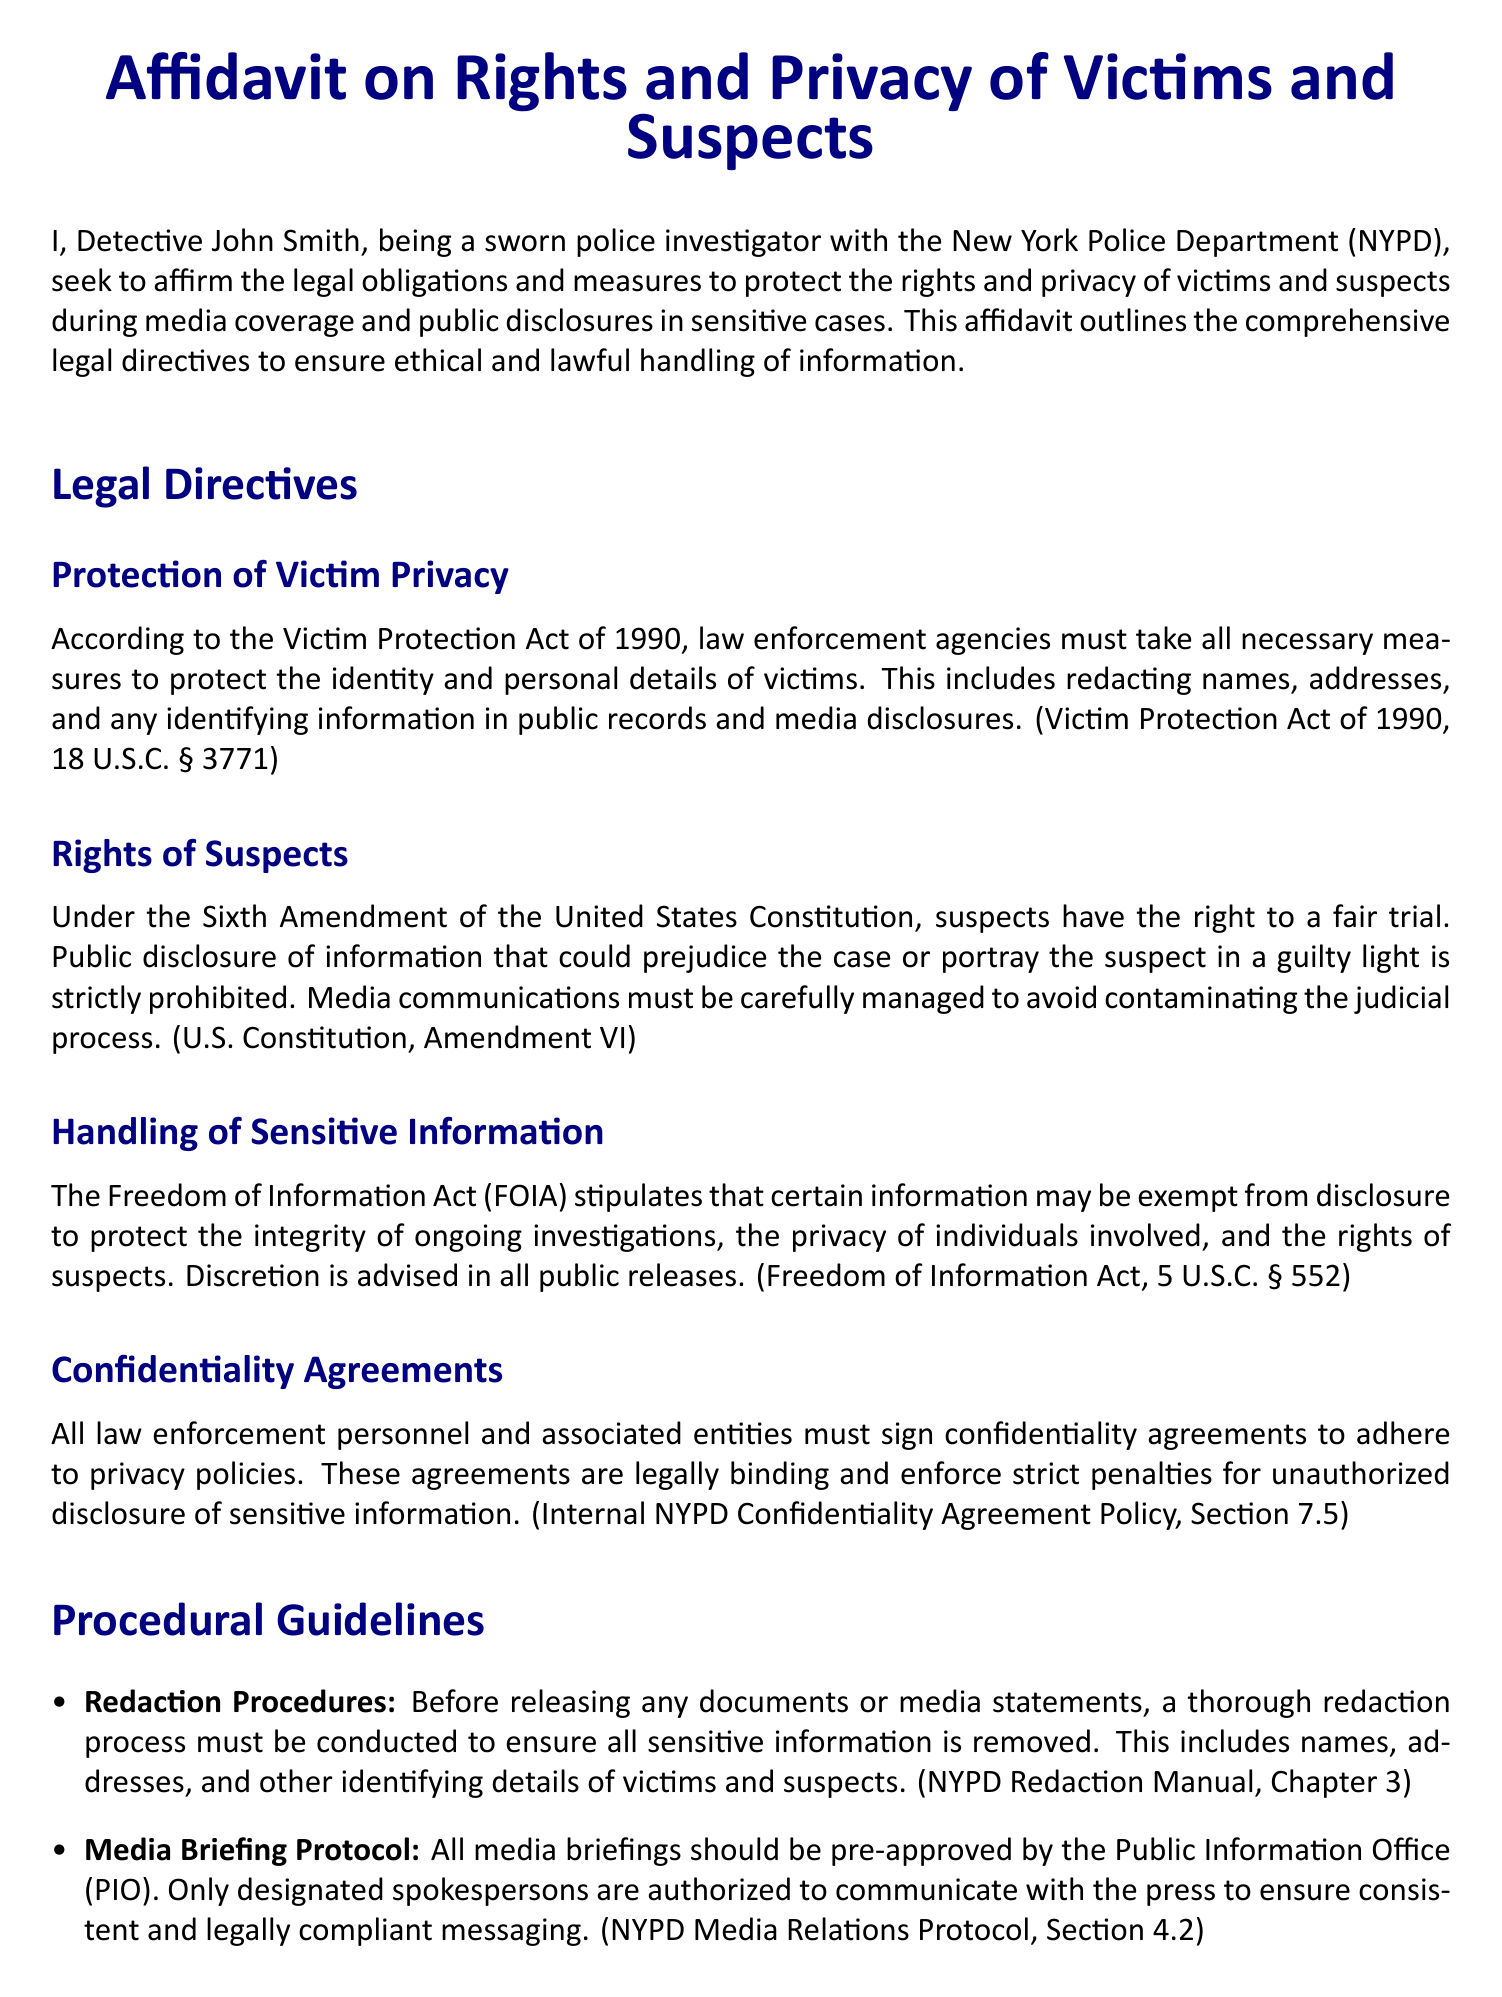What is the title of the document? The title of the document is stated clearly at the top, which is "Affidavit on Rights and Privacy of Victims and Suspects."
Answer: Affidavit on Rights and Privacy of Victims and Suspects Who is the affiant? The affiant is the person who swears to the affidavit, which is Detective John Smith.
Answer: Detective John Smith What is the date of the affidavit? The date is mentioned at the end, which signifies when the affidavit was signed.
Answer: October 15, 2023 Which act protects victim privacy? The act mentioned that protects victim privacy is called the Victim Protection Act of 1990.
Answer: Victim Protection Act of 1990 What amendment is referenced regarding suspects' rights? The Sixth Amendment of the United States Constitution is referenced in relation to suspects’ rights.
Answer: Sixth Amendment What is required before releasing documents or media statements? A thorough redaction process is required before releasing any documents or media statements.
Answer: Redaction process Who pre-approves media briefings? Media briefings must be pre-approved by the Public Information Office (PIO).
Answer: Public Information Office (PIO) What is the consequence for violating confidentiality agreements? Violating confidentiality agreements incurs strict penalties.
Answer: Strict penalties 